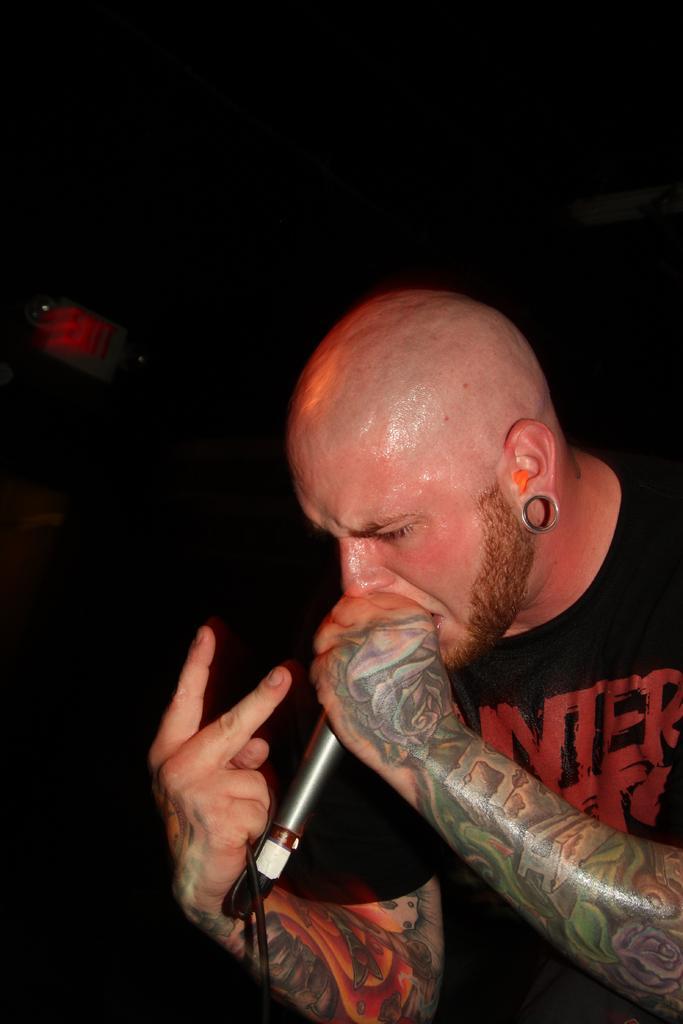In one or two sentences, can you explain what this image depicts? In this picture I can see a man singing with the help of a microphone and I can see a dark background. 